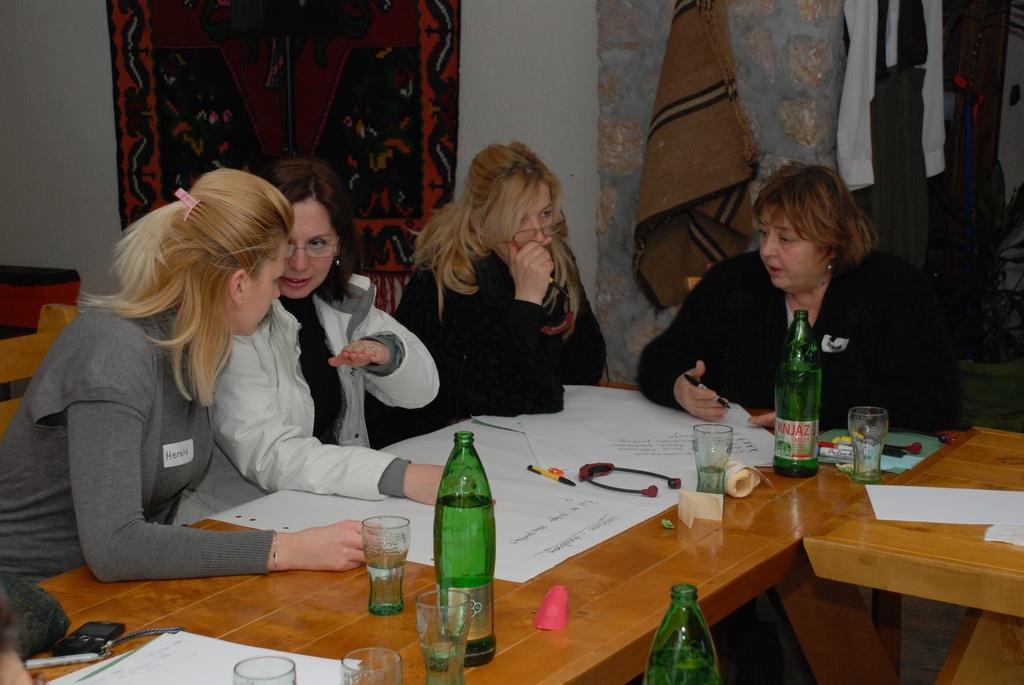Can you describe this image briefly? In the picture we can find four women sitting on the chairs near the table, on the table we can find some bottles, glasses, papers. In the background we can find a wall carpets and mats. 